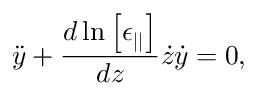Convert formula to latex. <formula><loc_0><loc_0><loc_500><loc_500>\ddot { y } + \frac { d \ln \left [ \epsilon _ { | | } \right ] } { d z } \dot { z } \dot { y } = 0 ,</formula> 